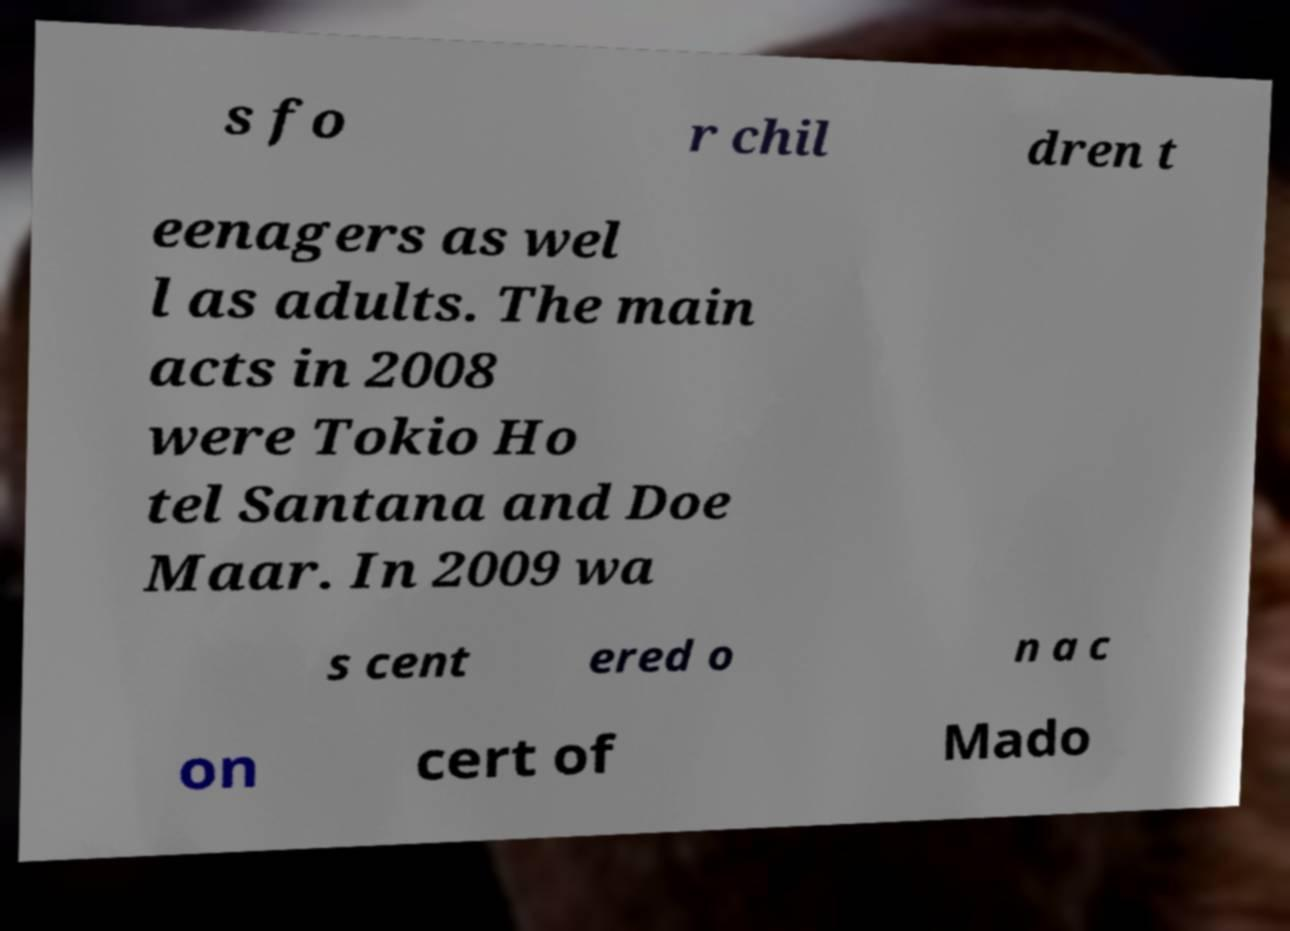For documentation purposes, I need the text within this image transcribed. Could you provide that? s fo r chil dren t eenagers as wel l as adults. The main acts in 2008 were Tokio Ho tel Santana and Doe Maar. In 2009 wa s cent ered o n a c on cert of Mado 